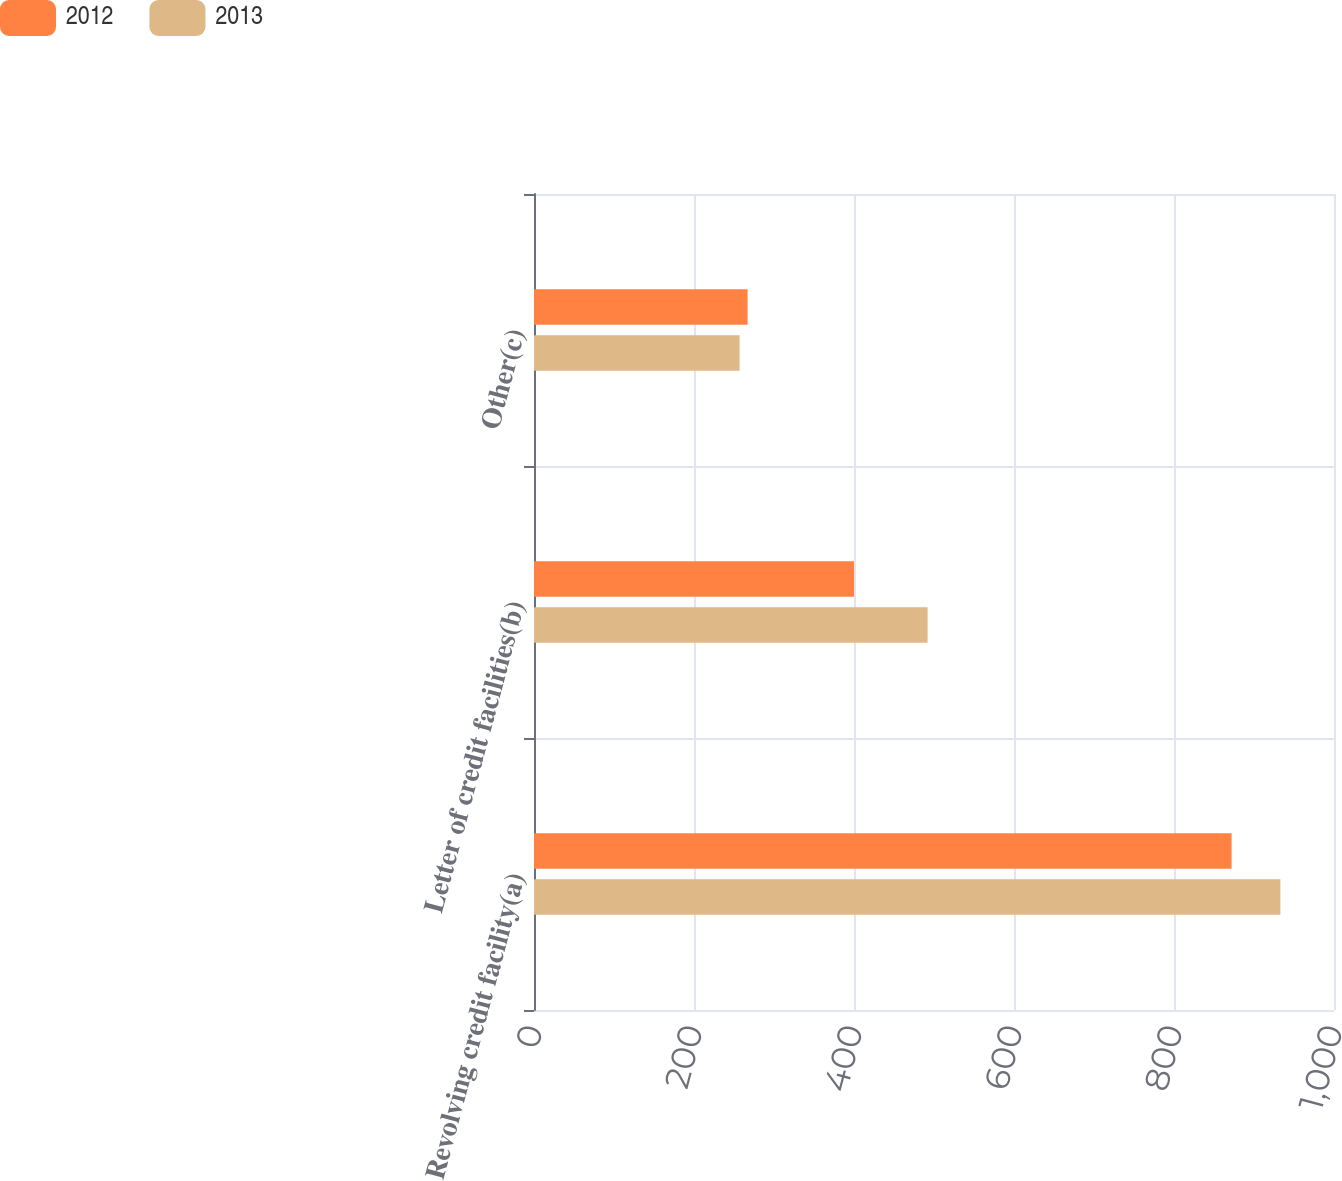<chart> <loc_0><loc_0><loc_500><loc_500><stacked_bar_chart><ecel><fcel>Revolving credit facility(a)<fcel>Letter of credit facilities(b)<fcel>Other(c)<nl><fcel>2012<fcel>872<fcel>400<fcel>267<nl><fcel>2013<fcel>933<fcel>492<fcel>257<nl></chart> 